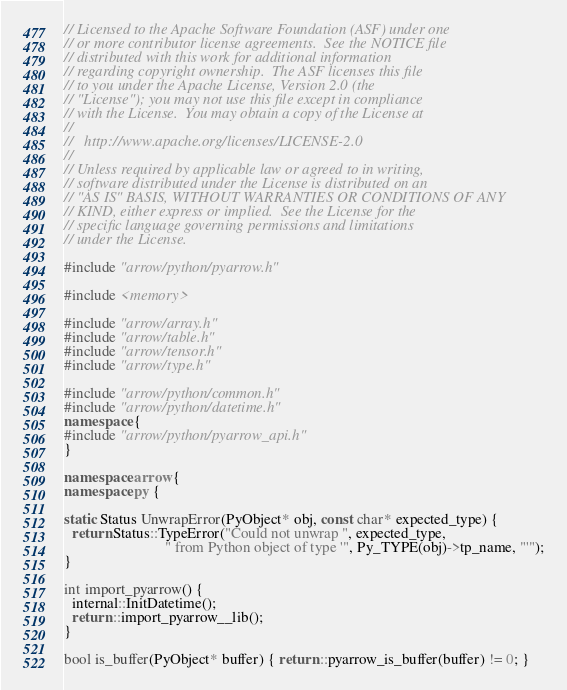<code> <loc_0><loc_0><loc_500><loc_500><_C++_>// Licensed to the Apache Software Foundation (ASF) under one
// or more contributor license agreements.  See the NOTICE file
// distributed with this work for additional information
// regarding copyright ownership.  The ASF licenses this file
// to you under the Apache License, Version 2.0 (the
// "License"); you may not use this file except in compliance
// with the License.  You may obtain a copy of the License at
//
//   http://www.apache.org/licenses/LICENSE-2.0
//
// Unless required by applicable law or agreed to in writing,
// software distributed under the License is distributed on an
// "AS IS" BASIS, WITHOUT WARRANTIES OR CONDITIONS OF ANY
// KIND, either express or implied.  See the License for the
// specific language governing permissions and limitations
// under the License.

#include "arrow/python/pyarrow.h"

#include <memory>

#include "arrow/array.h"
#include "arrow/table.h"
#include "arrow/tensor.h"
#include "arrow/type.h"

#include "arrow/python/common.h"
#include "arrow/python/datetime.h"
namespace {
#include "arrow/python/pyarrow_api.h"
}

namespace arrow {
namespace py {

static Status UnwrapError(PyObject* obj, const char* expected_type) {
  return Status::TypeError("Could not unwrap ", expected_type,
                           " from Python object of type '", Py_TYPE(obj)->tp_name, "'");
}

int import_pyarrow() {
  internal::InitDatetime();
  return ::import_pyarrow__lib();
}

bool is_buffer(PyObject* buffer) { return ::pyarrow_is_buffer(buffer) != 0; }
</code> 